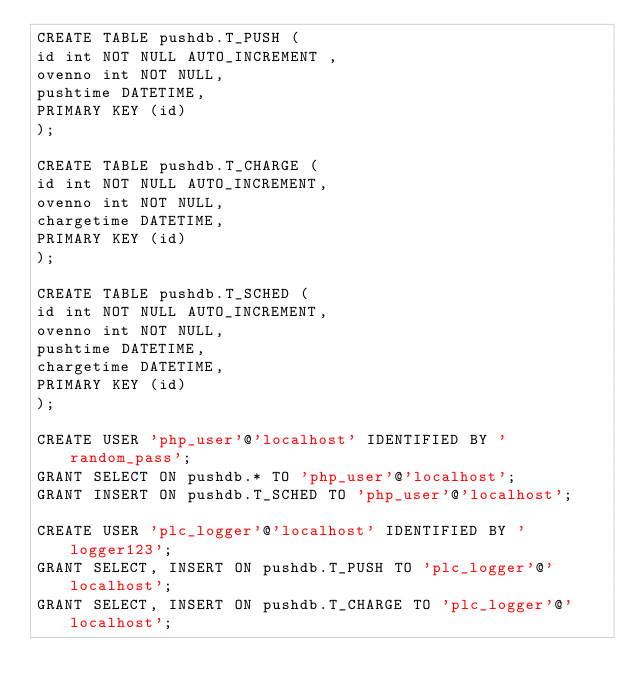Convert code to text. <code><loc_0><loc_0><loc_500><loc_500><_SQL_>CREATE TABLE pushdb.T_PUSH (
id int NOT NULL AUTO_INCREMENT ,
ovenno int NOT NULL,
pushtime DATETIME,
PRIMARY KEY (id)
);

CREATE TABLE pushdb.T_CHARGE (
id int NOT NULL AUTO_INCREMENT,
ovenno int NOT NULL,
chargetime DATETIME,
PRIMARY KEY (id)
);

CREATE TABLE pushdb.T_SCHED (
id int NOT NULL AUTO_INCREMENT,
ovenno int NOT NULL,
pushtime DATETIME,
chargetime DATETIME,
PRIMARY KEY (id)
);

CREATE USER 'php_user'@'localhost' IDENTIFIED BY 'random_pass';
GRANT SELECT ON pushdb.* TO 'php_user'@'localhost';
GRANT INSERT ON pushdb.T_SCHED TO 'php_user'@'localhost';

CREATE USER 'plc_logger'@'localhost' IDENTIFIED BY 'logger123';
GRANT SELECT, INSERT ON pushdb.T_PUSH TO 'plc_logger'@'localhost';
GRANT SELECT, INSERT ON pushdb.T_CHARGE TO 'plc_logger'@'localhost';</code> 